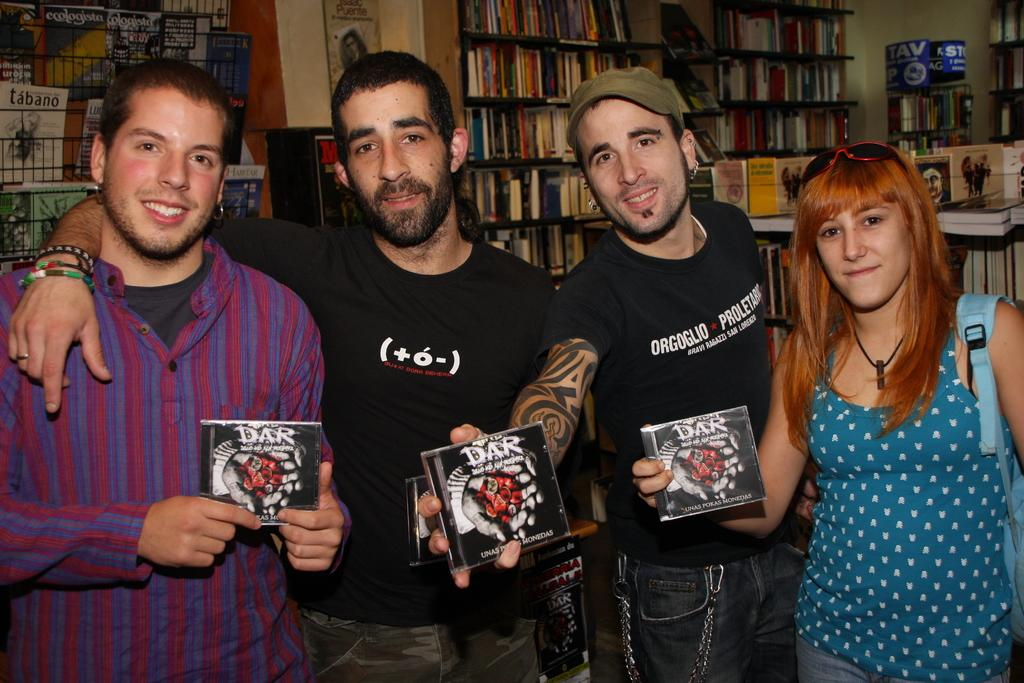How many people are present in the image? There are four people in the image: three men and one woman. What is the woman holding in the image? The woman is holding a book. What can be seen in the background of the image? There are racks with many books in the background of the image. Can you tell me how many times the woman sneezes in the image? There is no indication of anyone sneezing in the image. What type of test is being conducted in the image? There is no test being conducted in the image; it features four people and many books. 